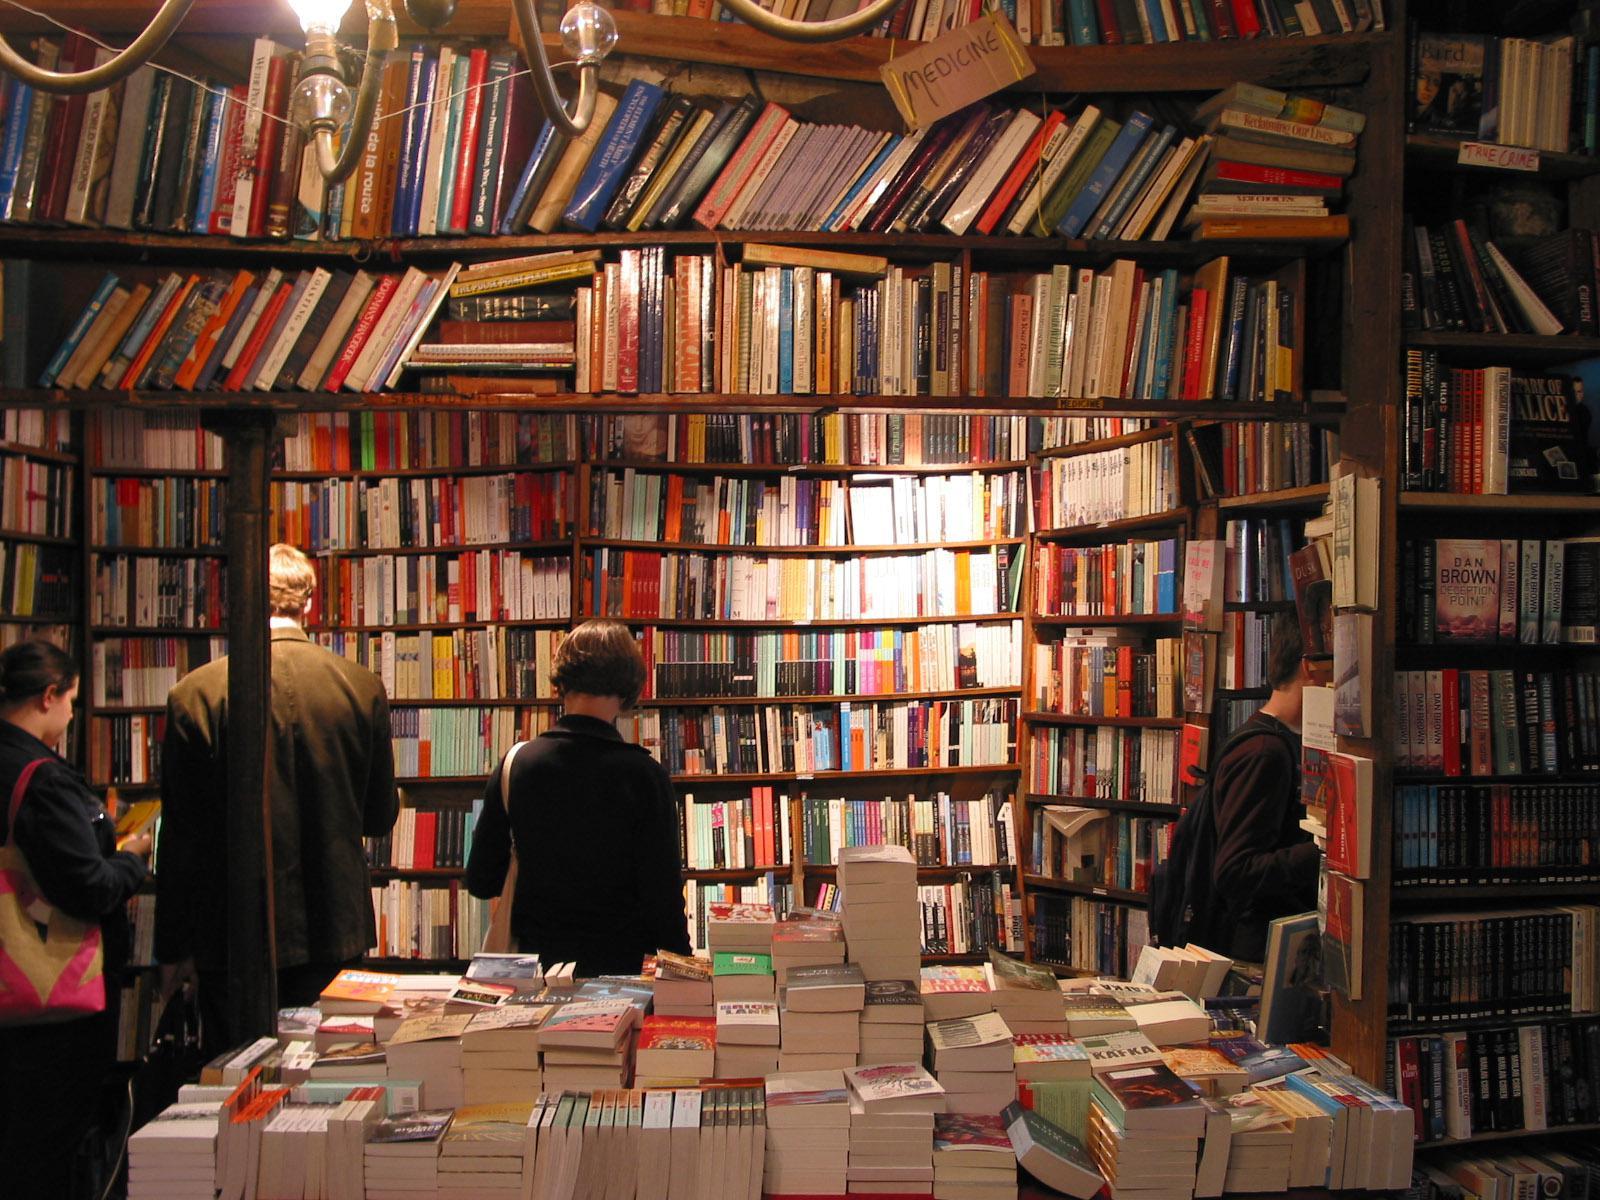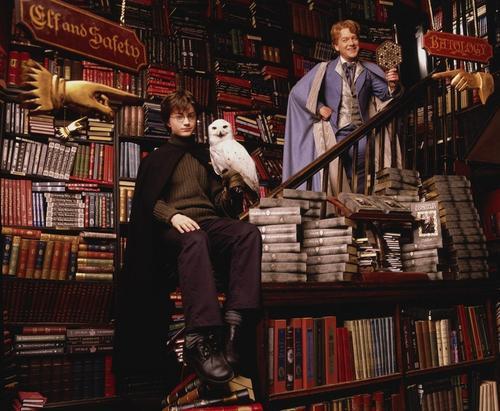The first image is the image on the left, the second image is the image on the right. Assess this claim about the two images: "There is at least one person looking at books on a shelf.". Correct or not? Answer yes or no. Yes. The first image is the image on the left, the second image is the image on the right. Evaluate the accuracy of this statement regarding the images: "The right image has visible windows, the left does not.". Is it true? Answer yes or no. No. 